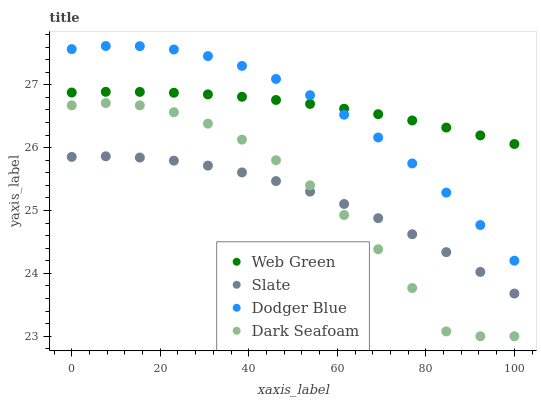Does Slate have the minimum area under the curve?
Answer yes or no. Yes. Does Web Green have the maximum area under the curve?
Answer yes or no. Yes. Does Dodger Blue have the minimum area under the curve?
Answer yes or no. No. Does Dodger Blue have the maximum area under the curve?
Answer yes or no. No. Is Web Green the smoothest?
Answer yes or no. Yes. Is Dark Seafoam the roughest?
Answer yes or no. Yes. Is Dodger Blue the smoothest?
Answer yes or no. No. Is Dodger Blue the roughest?
Answer yes or no. No. Does Dark Seafoam have the lowest value?
Answer yes or no. Yes. Does Dodger Blue have the lowest value?
Answer yes or no. No. Does Dodger Blue have the highest value?
Answer yes or no. Yes. Does Dark Seafoam have the highest value?
Answer yes or no. No. Is Slate less than Dodger Blue?
Answer yes or no. Yes. Is Web Green greater than Dark Seafoam?
Answer yes or no. Yes. Does Web Green intersect Dodger Blue?
Answer yes or no. Yes. Is Web Green less than Dodger Blue?
Answer yes or no. No. Is Web Green greater than Dodger Blue?
Answer yes or no. No. Does Slate intersect Dodger Blue?
Answer yes or no. No. 